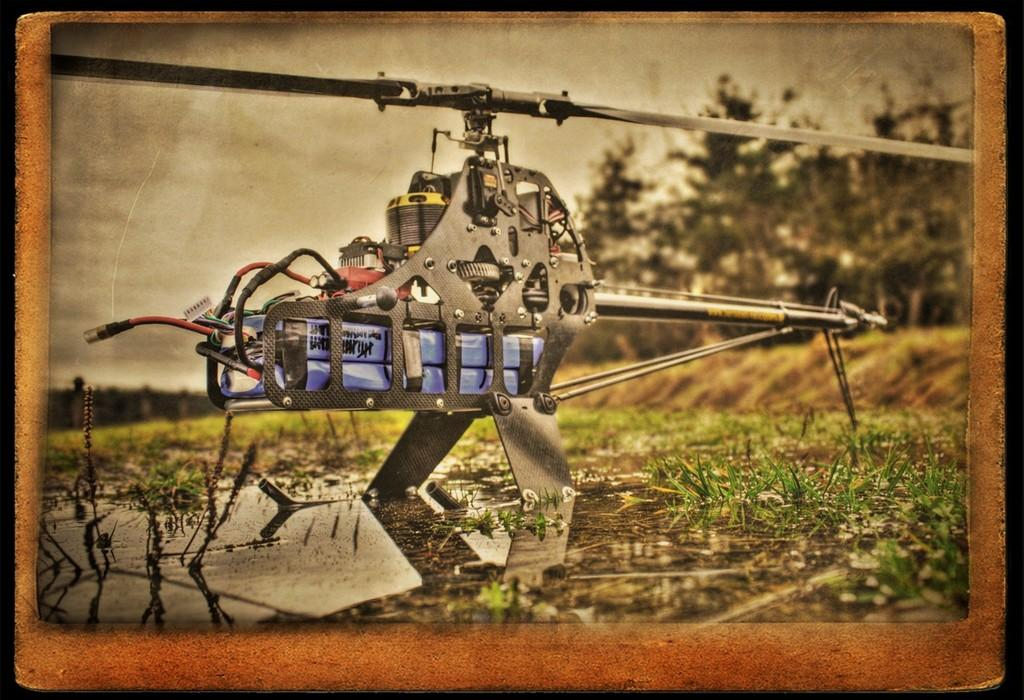What is the main object in the image? There is a frame in the image, and inside the frame, there is a helicopter-like machine. What is located at the bottom of the image? There is water and grass at the bottom of the image. What can be seen in the background of the image? There are trees and the sky visible in the background of the image. What type of poison is being used by the helicopter-like machine in the image? There is no mention of poison in the image, and the helicopter-like machine is not using any poison. 